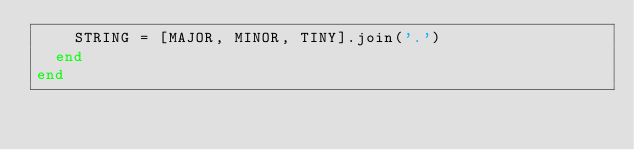<code> <loc_0><loc_0><loc_500><loc_500><_Ruby_>    STRING = [MAJOR, MINOR, TINY].join('.')
  end
end
</code> 